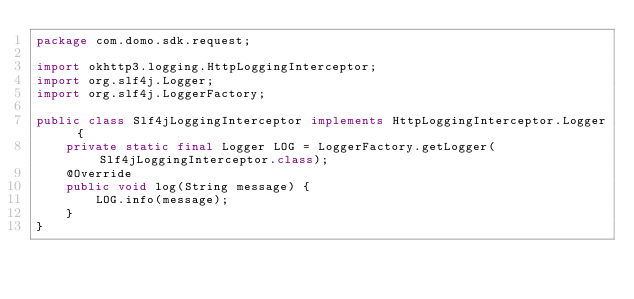<code> <loc_0><loc_0><loc_500><loc_500><_Java_>package com.domo.sdk.request;

import okhttp3.logging.HttpLoggingInterceptor;
import org.slf4j.Logger;
import org.slf4j.LoggerFactory;

public class Slf4jLoggingInterceptor implements HttpLoggingInterceptor.Logger {
    private static final Logger LOG = LoggerFactory.getLogger(Slf4jLoggingInterceptor.class);
    @Override
    public void log(String message) {
        LOG.info(message);
    }
}
</code> 